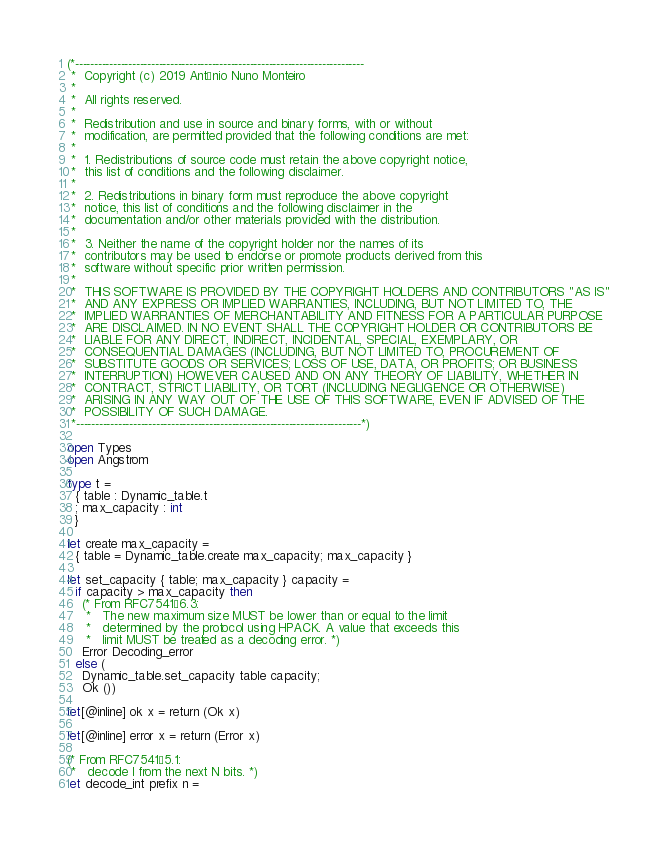Convert code to text. <code><loc_0><loc_0><loc_500><loc_500><_OCaml_>(*----------------------------------------------------------------------------
 *  Copyright (c) 2019 António Nuno Monteiro
 *
 *  All rights reserved.
 *
 *  Redistribution and use in source and binary forms, with or without
 *  modification, are permitted provided that the following conditions are met:
 *
 *  1. Redistributions of source code must retain the above copyright notice,
 *  this list of conditions and the following disclaimer.
 *
 *  2. Redistributions in binary form must reproduce the above copyright
 *  notice, this list of conditions and the following disclaimer in the
 *  documentation and/or other materials provided with the distribution.
 *
 *  3. Neither the name of the copyright holder nor the names of its
 *  contributors may be used to endorse or promote products derived from this
 *  software without specific prior written permission.
 *
 *  THIS SOFTWARE IS PROVIDED BY THE COPYRIGHT HOLDERS AND CONTRIBUTORS "AS IS"
 *  AND ANY EXPRESS OR IMPLIED WARRANTIES, INCLUDING, BUT NOT LIMITED TO, THE
 *  IMPLIED WARRANTIES OF MERCHANTABILITY AND FITNESS FOR A PARTICULAR PURPOSE
 *  ARE DISCLAIMED. IN NO EVENT SHALL THE COPYRIGHT HOLDER OR CONTRIBUTORS BE
 *  LIABLE FOR ANY DIRECT, INDIRECT, INCIDENTAL, SPECIAL, EXEMPLARY, OR
 *  CONSEQUENTIAL DAMAGES (INCLUDING, BUT NOT LIMITED TO, PROCUREMENT OF
 *  SUBSTITUTE GOODS OR SERVICES; LOSS OF USE, DATA, OR PROFITS; OR BUSINESS
 *  INTERRUPTION) HOWEVER CAUSED AND ON ANY THEORY OF LIABILITY, WHETHER IN
 *  CONTRACT, STRICT LIABILITY, OR TORT (INCLUDING NEGLIGENCE OR OTHERWISE)
 *  ARISING IN ANY WAY OUT OF THE USE OF THIS SOFTWARE, EVEN IF ADVISED OF THE
 *  POSSIBILITY OF SUCH DAMAGE.
 *---------------------------------------------------------------------------*)

open Types
open Angstrom

type t =
  { table : Dynamic_table.t
  ; max_capacity : int
  }

let create max_capacity =
  { table = Dynamic_table.create max_capacity; max_capacity }

let set_capacity { table; max_capacity } capacity =
  if capacity > max_capacity then
    (* From RFC7541§6.3:
     *   The new maximum size MUST be lower than or equal to the limit
     *   determined by the protocol using HPACK. A value that exceeds this
     *   limit MUST be treated as a decoding error. *)
    Error Decoding_error
  else (
    Dynamic_table.set_capacity table capacity;
    Ok ())

let[@inline] ok x = return (Ok x)

let[@inline] error x = return (Error x)

(* From RFC7541§5.1:
 *   decode I from the next N bits. *)
let decode_int prefix n =</code> 